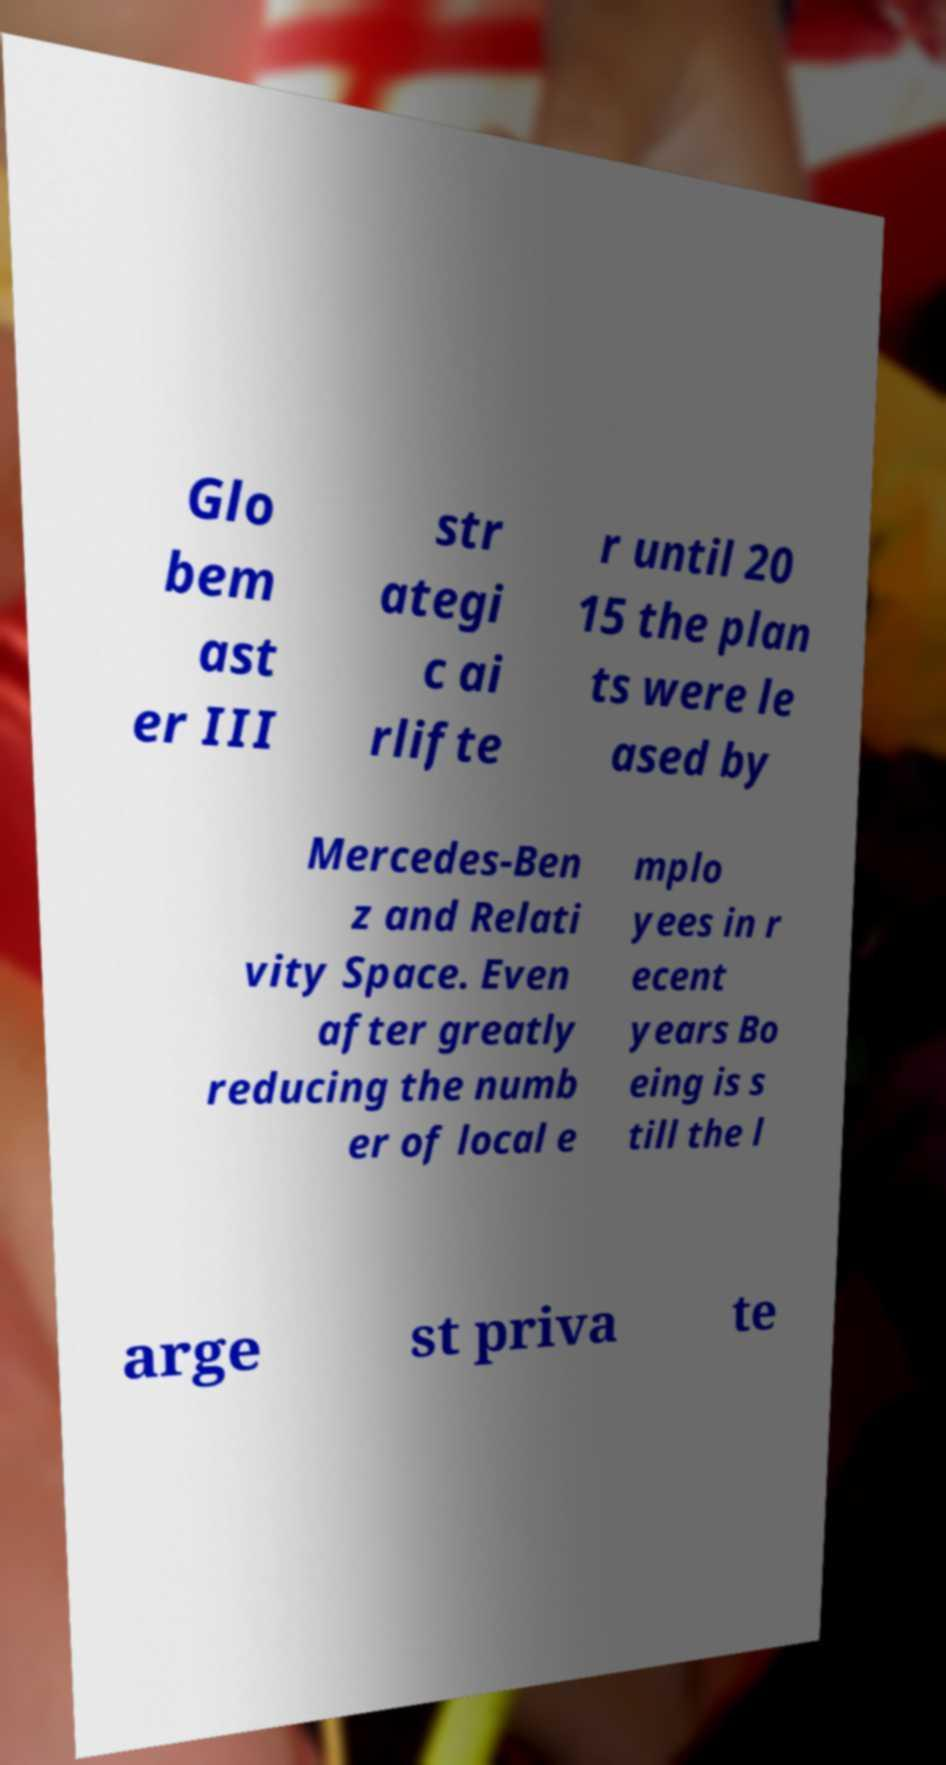For documentation purposes, I need the text within this image transcribed. Could you provide that? Glo bem ast er III str ategi c ai rlifte r until 20 15 the plan ts were le ased by Mercedes-Ben z and Relati vity Space. Even after greatly reducing the numb er of local e mplo yees in r ecent years Bo eing is s till the l arge st priva te 